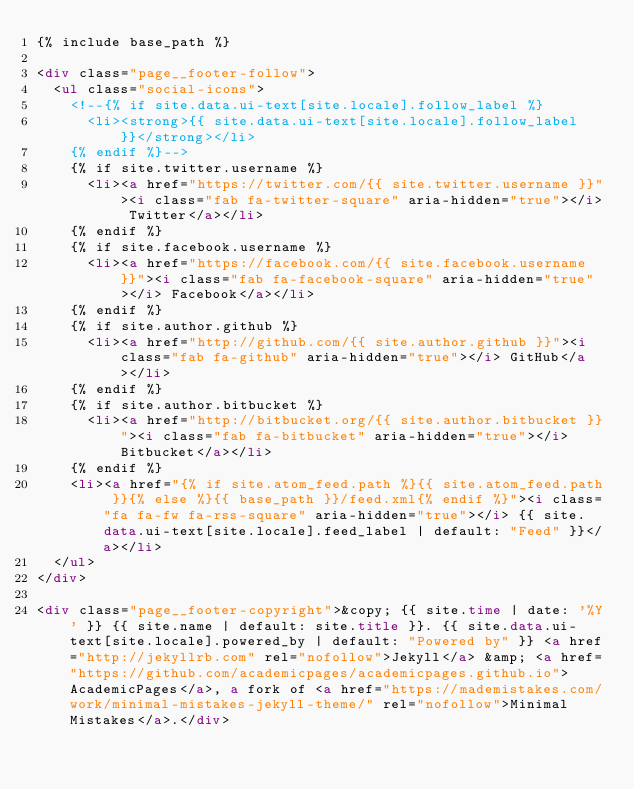<code> <loc_0><loc_0><loc_500><loc_500><_HTML_>{% include base_path %}

<div class="page__footer-follow">
  <ul class="social-icons">
    <!--{% if site.data.ui-text[site.locale].follow_label %}
      <li><strong>{{ site.data.ui-text[site.locale].follow_label }}</strong></li>
    {% endif %}-->
    {% if site.twitter.username %}
      <li><a href="https://twitter.com/{{ site.twitter.username }}"><i class="fab fa-twitter-square" aria-hidden="true"></i> Twitter</a></li>
    {% endif %}
    {% if site.facebook.username %}
      <li><a href="https://facebook.com/{{ site.facebook.username }}"><i class="fab fa-facebook-square" aria-hidden="true"></i> Facebook</a></li>
    {% endif %}
    {% if site.author.github %}
      <li><a href="http://github.com/{{ site.author.github }}"><i class="fab fa-github" aria-hidden="true"></i> GitHub</a></li>
    {% endif %}
    {% if site.author.bitbucket %}
      <li><a href="http://bitbucket.org/{{ site.author.bitbucket }}"><i class="fab fa-bitbucket" aria-hidden="true"></i> Bitbucket</a></li>
    {% endif %}
    <li><a href="{% if site.atom_feed.path %}{{ site.atom_feed.path }}{% else %}{{ base_path }}/feed.xml{% endif %}"><i class="fa fa-fw fa-rss-square" aria-hidden="true"></i> {{ site.data.ui-text[site.locale].feed_label | default: "Feed" }}</a></li>
  </ul>
</div>

<div class="page__footer-copyright">&copy; {{ site.time | date: '%Y' }} {{ site.name | default: site.title }}. {{ site.data.ui-text[site.locale].powered_by | default: "Powered by" }} <a href="http://jekyllrb.com" rel="nofollow">Jekyll</a> &amp; <a href="https://github.com/academicpages/academicpages.github.io">AcademicPages</a>, a fork of <a href="https://mademistakes.com/work/minimal-mistakes-jekyll-theme/" rel="nofollow">Minimal Mistakes</a>.</div>
</code> 